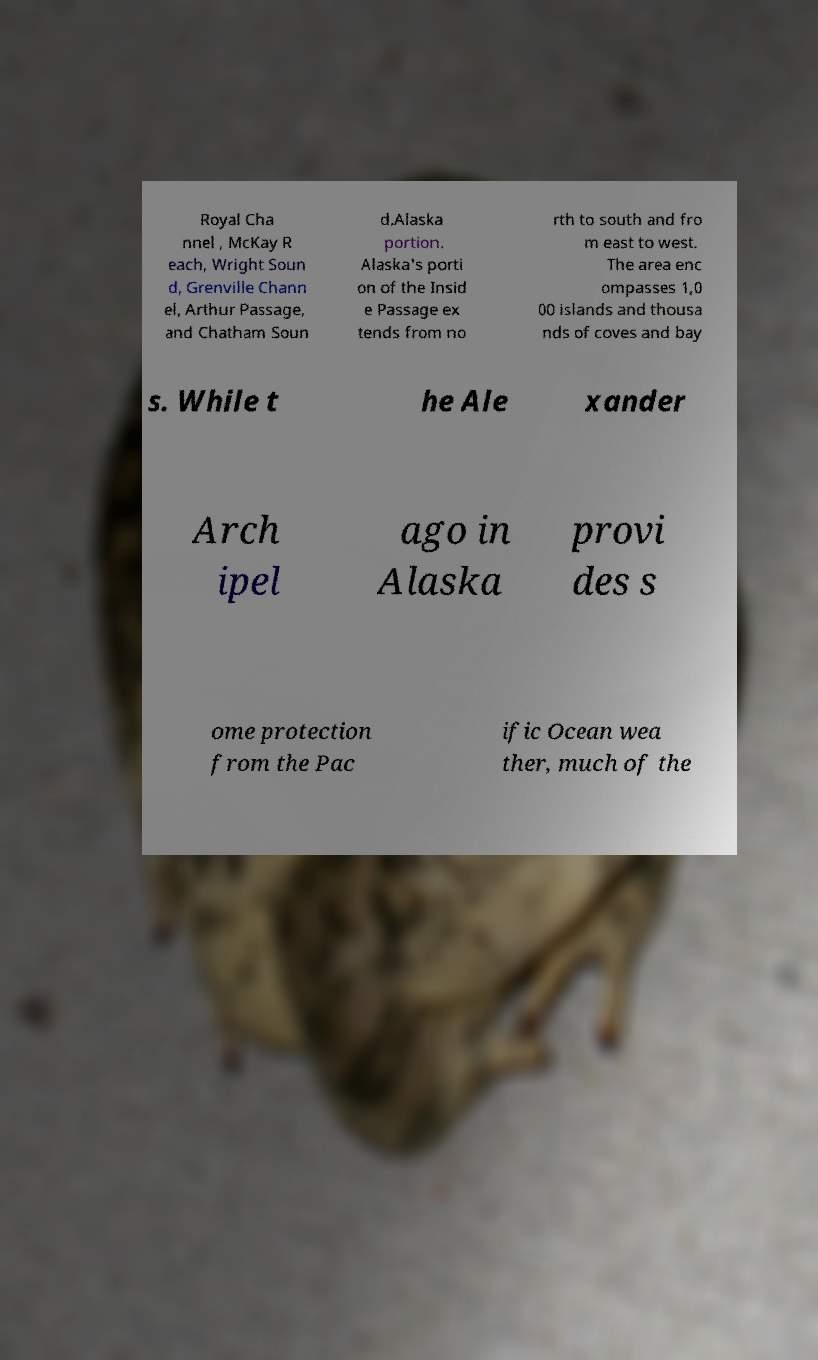I need the written content from this picture converted into text. Can you do that? Royal Cha nnel , McKay R each, Wright Soun d, Grenville Chann el, Arthur Passage, and Chatham Soun d.Alaska portion. Alaska's porti on of the Insid e Passage ex tends from no rth to south and fro m east to west. The area enc ompasses 1,0 00 islands and thousa nds of coves and bay s. While t he Ale xander Arch ipel ago in Alaska provi des s ome protection from the Pac ific Ocean wea ther, much of the 